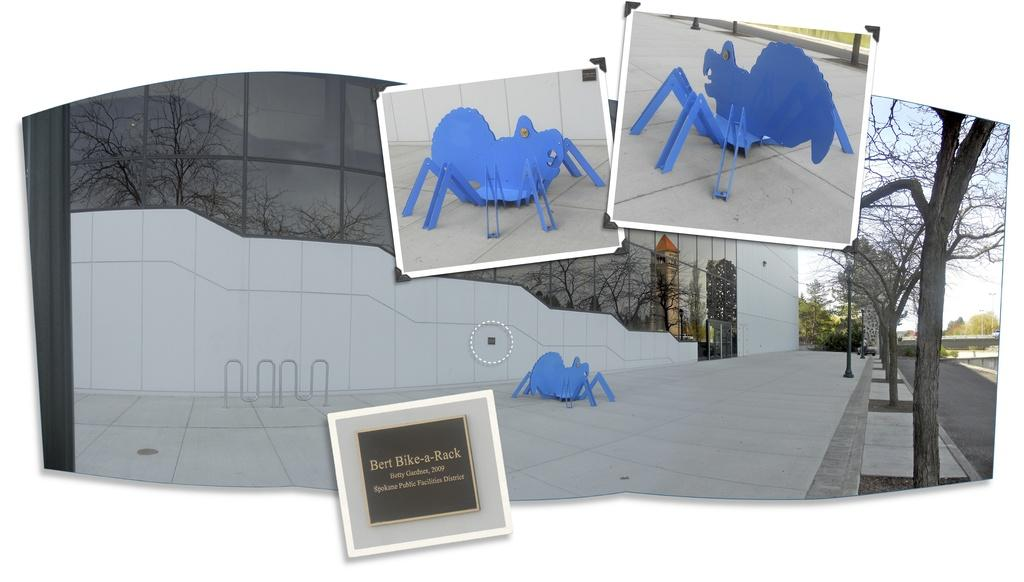Provide a one-sentence caption for the provided image. A spider statue sits next to a plaque that says Bert Bike-a-Rack. 